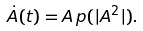Convert formula to latex. <formula><loc_0><loc_0><loc_500><loc_500>\dot { A } ( t ) = A \, p ( | A ^ { 2 } | ) .</formula> 